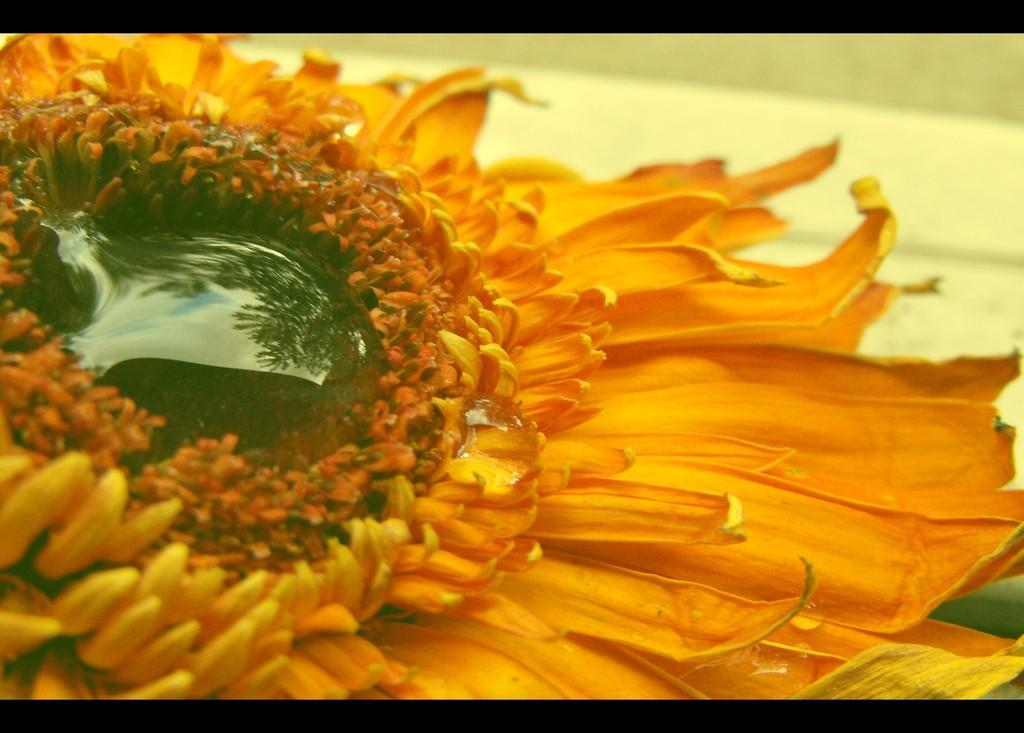What is the main subject of the image? There is a flower in the image. What type of bead is used to represent the brain in the image? There is no bead or representation of a brain present in the image; it features a flower. 